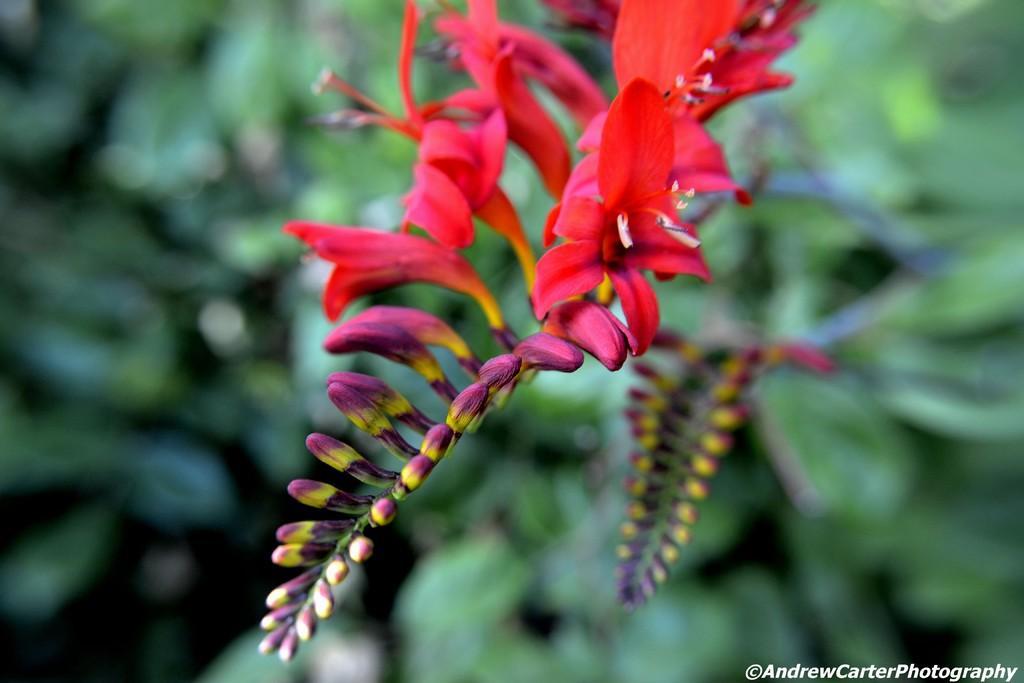Can you describe this image briefly? In the picture I can see the red color flowering plants. 